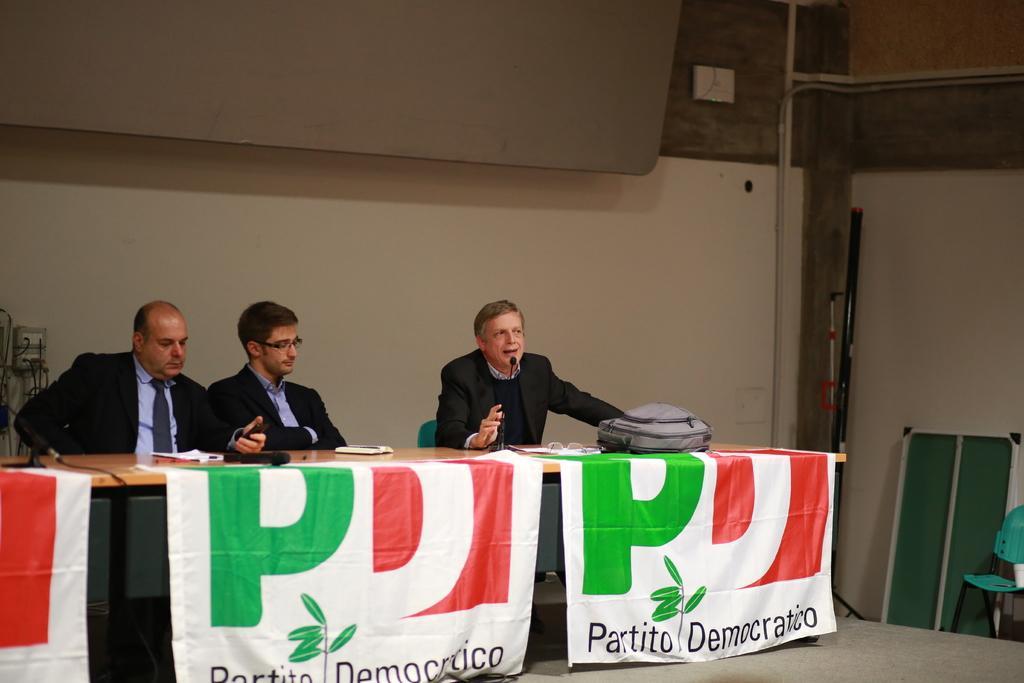Describe this image in one or two sentences. In this image we can see men sitting on the chairs and a table is placed in front of them. On the table we can see mics, cables, papers, bag and advertisements. In the background there are pipelines and planks on the floor. 